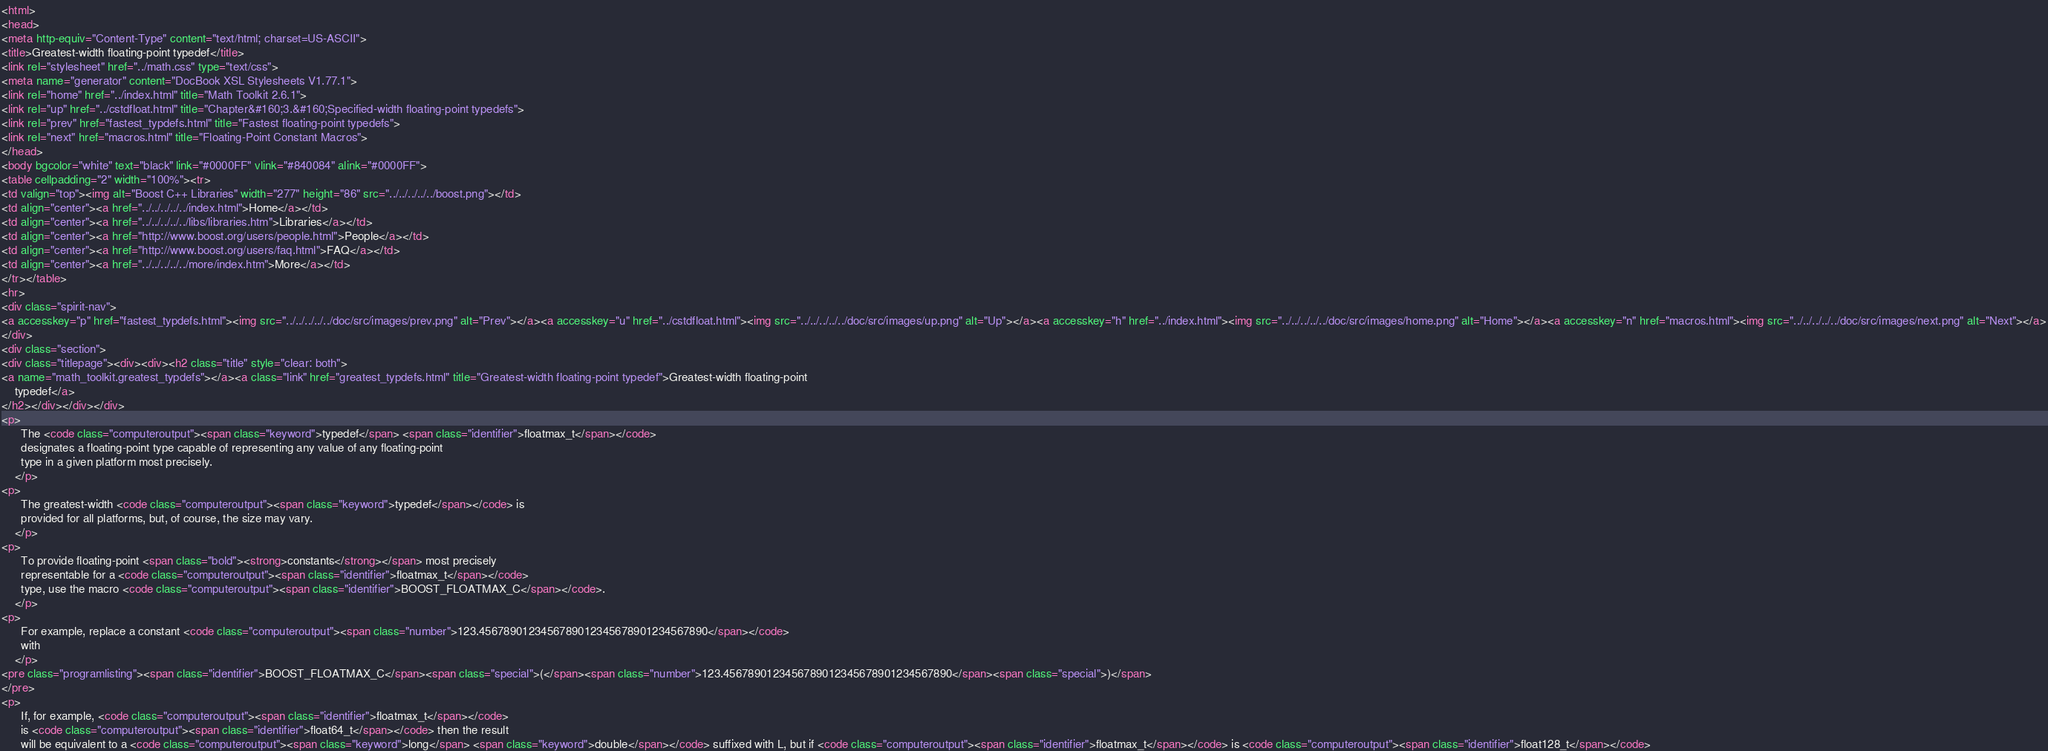<code> <loc_0><loc_0><loc_500><loc_500><_HTML_><html>
<head>
<meta http-equiv="Content-Type" content="text/html; charset=US-ASCII">
<title>Greatest-width floating-point typedef</title>
<link rel="stylesheet" href="../math.css" type="text/css">
<meta name="generator" content="DocBook XSL Stylesheets V1.77.1">
<link rel="home" href="../index.html" title="Math Toolkit 2.6.1">
<link rel="up" href="../cstdfloat.html" title="Chapter&#160;3.&#160;Specified-width floating-point typedefs">
<link rel="prev" href="fastest_typdefs.html" title="Fastest floating-point typedefs">
<link rel="next" href="macros.html" title="Floating-Point Constant Macros">
</head>
<body bgcolor="white" text="black" link="#0000FF" vlink="#840084" alink="#0000FF">
<table cellpadding="2" width="100%"><tr>
<td valign="top"><img alt="Boost C++ Libraries" width="277" height="86" src="../../../../../boost.png"></td>
<td align="center"><a href="../../../../../index.html">Home</a></td>
<td align="center"><a href="../../../../../libs/libraries.htm">Libraries</a></td>
<td align="center"><a href="http://www.boost.org/users/people.html">People</a></td>
<td align="center"><a href="http://www.boost.org/users/faq.html">FAQ</a></td>
<td align="center"><a href="../../../../../more/index.htm">More</a></td>
</tr></table>
<hr>
<div class="spirit-nav">
<a accesskey="p" href="fastest_typdefs.html"><img src="../../../../../doc/src/images/prev.png" alt="Prev"></a><a accesskey="u" href="../cstdfloat.html"><img src="../../../../../doc/src/images/up.png" alt="Up"></a><a accesskey="h" href="../index.html"><img src="../../../../../doc/src/images/home.png" alt="Home"></a><a accesskey="n" href="macros.html"><img src="../../../../../doc/src/images/next.png" alt="Next"></a>
</div>
<div class="section">
<div class="titlepage"><div><div><h2 class="title" style="clear: both">
<a name="math_toolkit.greatest_typdefs"></a><a class="link" href="greatest_typdefs.html" title="Greatest-width floating-point typedef">Greatest-width floating-point
    typedef</a>
</h2></div></div></div>
<p>
      The <code class="computeroutput"><span class="keyword">typedef</span> <span class="identifier">floatmax_t</span></code>
      designates a floating-point type capable of representing any value of any floating-point
      type in a given platform most precisely.
    </p>
<p>
      The greatest-width <code class="computeroutput"><span class="keyword">typedef</span></code> is
      provided for all platforms, but, of course, the size may vary.
    </p>
<p>
      To provide floating-point <span class="bold"><strong>constants</strong></span> most precisely
      representable for a <code class="computeroutput"><span class="identifier">floatmax_t</span></code>
      type, use the macro <code class="computeroutput"><span class="identifier">BOOST_FLOATMAX_C</span></code>.
    </p>
<p>
      For example, replace a constant <code class="computeroutput"><span class="number">123.4567890123456789012345678901234567890</span></code>
      with
    </p>
<pre class="programlisting"><span class="identifier">BOOST_FLOATMAX_C</span><span class="special">(</span><span class="number">123.4567890123456789012345678901234567890</span><span class="special">)</span>
</pre>
<p>
      If, for example, <code class="computeroutput"><span class="identifier">floatmax_t</span></code>
      is <code class="computeroutput"><span class="identifier">float64_t</span></code> then the result
      will be equivalent to a <code class="computeroutput"><span class="keyword">long</span> <span class="keyword">double</span></code> suffixed with L, but if <code class="computeroutput"><span class="identifier">floatmax_t</span></code> is <code class="computeroutput"><span class="identifier">float128_t</span></code></code> 